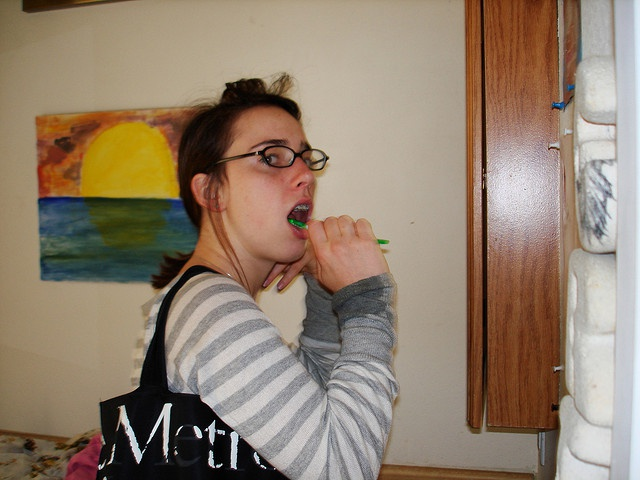Describe the objects in this image and their specific colors. I can see people in olive, darkgray, black, brown, and gray tones, handbag in olive, black, lightgray, darkgray, and gray tones, and toothbrush in olive, darkgreen, and green tones in this image. 